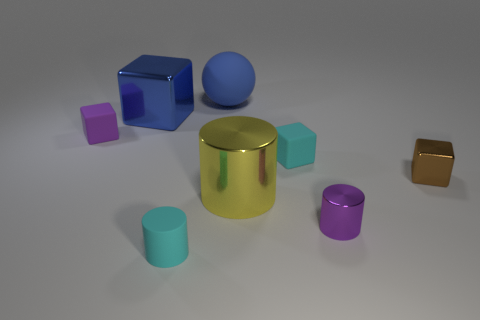Are there any other things that have the same material as the purple block?
Offer a very short reply. Yes. What number of blocks are tiny brown objects or small purple rubber things?
Ensure brevity in your answer.  2. What is the shape of the shiny thing that is to the right of the tiny purple metal thing?
Keep it short and to the point. Cube. What number of large blue objects are made of the same material as the cyan cylinder?
Provide a succinct answer. 1. Are there fewer big yellow shiny things on the right side of the big blue shiny cube than small cyan cylinders?
Provide a succinct answer. No. There is a shiny block that is in front of the purple thing behind the small purple cylinder; what is its size?
Provide a succinct answer. Small. Does the big block have the same color as the rubber thing in front of the brown cube?
Make the answer very short. No. There is a purple block that is the same size as the brown cube; what material is it?
Your answer should be compact. Rubber. Is the number of blue cubes in front of the tiny cyan rubber cylinder less than the number of large blue matte things in front of the big yellow thing?
Offer a terse response. No. What is the shape of the small matte thing in front of the small cyan matte thing right of the large metal cylinder?
Your answer should be compact. Cylinder. 